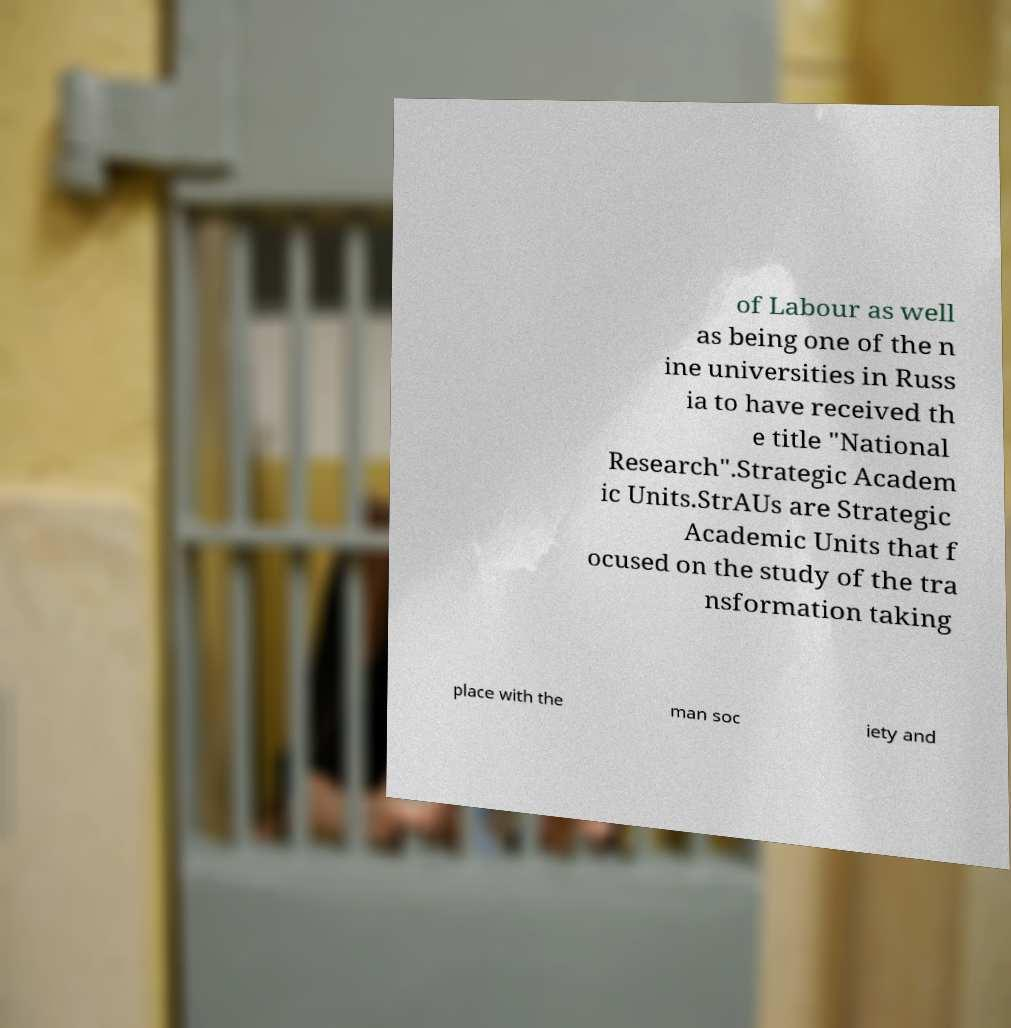Could you extract and type out the text from this image? of Labour as well as being one of the n ine universities in Russ ia to have received th e title "National Research".Strategic Academ ic Units.StrAUs are Strategic Academic Units that f ocused on the study of the tra nsformation taking place with the man soc iety and 